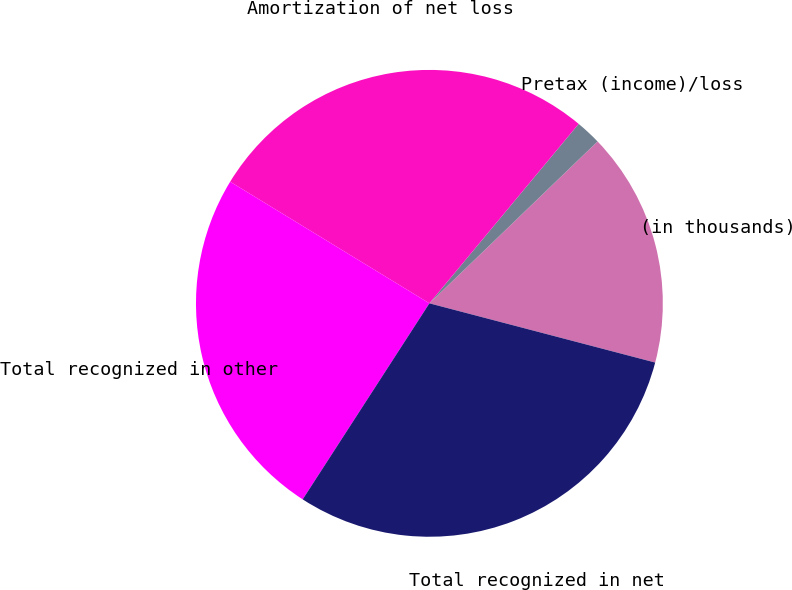Convert chart. <chart><loc_0><loc_0><loc_500><loc_500><pie_chart><fcel>(in thousands)<fcel>Pretax (income)/loss<fcel>Amortization of net loss<fcel>Total recognized in other<fcel>Total recognized in net<nl><fcel>16.28%<fcel>1.76%<fcel>27.32%<fcel>24.59%<fcel>30.05%<nl></chart> 